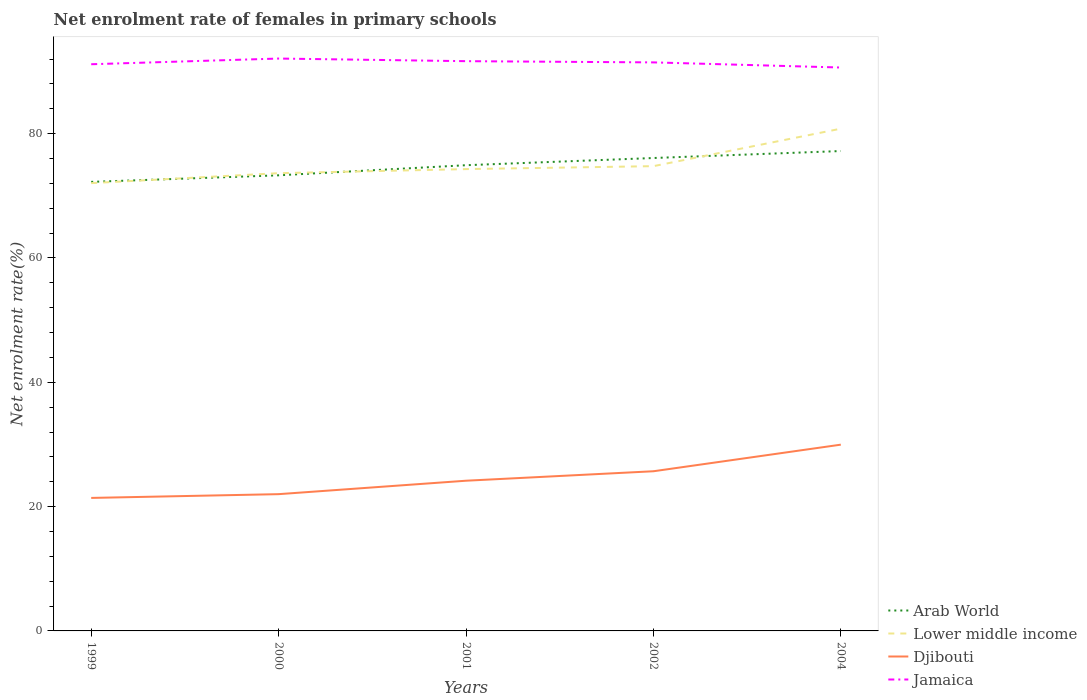How many different coloured lines are there?
Ensure brevity in your answer.  4. Is the number of lines equal to the number of legend labels?
Offer a very short reply. Yes. Across all years, what is the maximum net enrolment rate of females in primary schools in Lower middle income?
Your answer should be very brief. 72.04. What is the total net enrolment rate of females in primary schools in Arab World in the graph?
Offer a terse response. -1.12. What is the difference between the highest and the second highest net enrolment rate of females in primary schools in Jamaica?
Keep it short and to the point. 1.44. How many years are there in the graph?
Your response must be concise. 5. What is the difference between two consecutive major ticks on the Y-axis?
Provide a short and direct response. 20. Are the values on the major ticks of Y-axis written in scientific E-notation?
Offer a terse response. No. Does the graph contain any zero values?
Give a very brief answer. No. Where does the legend appear in the graph?
Keep it short and to the point. Bottom right. How many legend labels are there?
Offer a terse response. 4. What is the title of the graph?
Your response must be concise. Net enrolment rate of females in primary schools. Does "Egypt, Arab Rep." appear as one of the legend labels in the graph?
Your answer should be very brief. No. What is the label or title of the X-axis?
Offer a terse response. Years. What is the label or title of the Y-axis?
Your answer should be very brief. Net enrolment rate(%). What is the Net enrolment rate(%) in Arab World in 1999?
Your response must be concise. 72.25. What is the Net enrolment rate(%) in Lower middle income in 1999?
Offer a terse response. 72.04. What is the Net enrolment rate(%) in Djibouti in 1999?
Keep it short and to the point. 21.4. What is the Net enrolment rate(%) in Jamaica in 1999?
Your answer should be compact. 91.17. What is the Net enrolment rate(%) in Arab World in 2000?
Provide a short and direct response. 73.3. What is the Net enrolment rate(%) of Lower middle income in 2000?
Keep it short and to the point. 73.64. What is the Net enrolment rate(%) in Djibouti in 2000?
Offer a terse response. 22. What is the Net enrolment rate(%) in Jamaica in 2000?
Offer a very short reply. 92.09. What is the Net enrolment rate(%) in Arab World in 2001?
Provide a succinct answer. 74.93. What is the Net enrolment rate(%) of Lower middle income in 2001?
Offer a terse response. 74.3. What is the Net enrolment rate(%) in Djibouti in 2001?
Give a very brief answer. 24.17. What is the Net enrolment rate(%) in Jamaica in 2001?
Keep it short and to the point. 91.67. What is the Net enrolment rate(%) of Arab World in 2002?
Provide a succinct answer. 76.09. What is the Net enrolment rate(%) of Lower middle income in 2002?
Provide a succinct answer. 74.78. What is the Net enrolment rate(%) of Djibouti in 2002?
Provide a short and direct response. 25.69. What is the Net enrolment rate(%) of Jamaica in 2002?
Offer a very short reply. 91.47. What is the Net enrolment rate(%) of Arab World in 2004?
Keep it short and to the point. 77.21. What is the Net enrolment rate(%) of Lower middle income in 2004?
Offer a terse response. 80.8. What is the Net enrolment rate(%) of Djibouti in 2004?
Ensure brevity in your answer.  29.97. What is the Net enrolment rate(%) in Jamaica in 2004?
Your answer should be compact. 90.64. Across all years, what is the maximum Net enrolment rate(%) of Arab World?
Offer a very short reply. 77.21. Across all years, what is the maximum Net enrolment rate(%) in Lower middle income?
Make the answer very short. 80.8. Across all years, what is the maximum Net enrolment rate(%) of Djibouti?
Ensure brevity in your answer.  29.97. Across all years, what is the maximum Net enrolment rate(%) of Jamaica?
Offer a terse response. 92.09. Across all years, what is the minimum Net enrolment rate(%) of Arab World?
Your response must be concise. 72.25. Across all years, what is the minimum Net enrolment rate(%) of Lower middle income?
Make the answer very short. 72.04. Across all years, what is the minimum Net enrolment rate(%) in Djibouti?
Provide a short and direct response. 21.4. Across all years, what is the minimum Net enrolment rate(%) of Jamaica?
Offer a terse response. 90.64. What is the total Net enrolment rate(%) of Arab World in the graph?
Offer a terse response. 373.77. What is the total Net enrolment rate(%) of Lower middle income in the graph?
Your response must be concise. 375.57. What is the total Net enrolment rate(%) in Djibouti in the graph?
Keep it short and to the point. 123.22. What is the total Net enrolment rate(%) of Jamaica in the graph?
Ensure brevity in your answer.  457.04. What is the difference between the Net enrolment rate(%) of Arab World in 1999 and that in 2000?
Provide a short and direct response. -1.06. What is the difference between the Net enrolment rate(%) of Lower middle income in 1999 and that in 2000?
Make the answer very short. -1.6. What is the difference between the Net enrolment rate(%) of Djibouti in 1999 and that in 2000?
Your answer should be very brief. -0.61. What is the difference between the Net enrolment rate(%) of Jamaica in 1999 and that in 2000?
Make the answer very short. -0.92. What is the difference between the Net enrolment rate(%) in Arab World in 1999 and that in 2001?
Give a very brief answer. -2.68. What is the difference between the Net enrolment rate(%) in Lower middle income in 1999 and that in 2001?
Provide a short and direct response. -2.26. What is the difference between the Net enrolment rate(%) in Djibouti in 1999 and that in 2001?
Offer a terse response. -2.77. What is the difference between the Net enrolment rate(%) of Jamaica in 1999 and that in 2001?
Provide a succinct answer. -0.49. What is the difference between the Net enrolment rate(%) in Arab World in 1999 and that in 2002?
Make the answer very short. -3.84. What is the difference between the Net enrolment rate(%) of Lower middle income in 1999 and that in 2002?
Your response must be concise. -2.73. What is the difference between the Net enrolment rate(%) of Djibouti in 1999 and that in 2002?
Make the answer very short. -4.29. What is the difference between the Net enrolment rate(%) of Jamaica in 1999 and that in 2002?
Ensure brevity in your answer.  -0.3. What is the difference between the Net enrolment rate(%) of Arab World in 1999 and that in 2004?
Ensure brevity in your answer.  -4.96. What is the difference between the Net enrolment rate(%) in Lower middle income in 1999 and that in 2004?
Offer a terse response. -8.76. What is the difference between the Net enrolment rate(%) of Djibouti in 1999 and that in 2004?
Provide a succinct answer. -8.57. What is the difference between the Net enrolment rate(%) in Jamaica in 1999 and that in 2004?
Make the answer very short. 0.53. What is the difference between the Net enrolment rate(%) in Arab World in 2000 and that in 2001?
Your answer should be very brief. -1.63. What is the difference between the Net enrolment rate(%) in Lower middle income in 2000 and that in 2001?
Your answer should be very brief. -0.66. What is the difference between the Net enrolment rate(%) of Djibouti in 2000 and that in 2001?
Your answer should be very brief. -2.16. What is the difference between the Net enrolment rate(%) of Jamaica in 2000 and that in 2001?
Provide a succinct answer. 0.42. What is the difference between the Net enrolment rate(%) of Arab World in 2000 and that in 2002?
Ensure brevity in your answer.  -2.78. What is the difference between the Net enrolment rate(%) in Lower middle income in 2000 and that in 2002?
Provide a short and direct response. -1.13. What is the difference between the Net enrolment rate(%) in Djibouti in 2000 and that in 2002?
Make the answer very short. -3.68. What is the difference between the Net enrolment rate(%) in Jamaica in 2000 and that in 2002?
Offer a terse response. 0.62. What is the difference between the Net enrolment rate(%) of Arab World in 2000 and that in 2004?
Your answer should be compact. -3.9. What is the difference between the Net enrolment rate(%) of Lower middle income in 2000 and that in 2004?
Give a very brief answer. -7.16. What is the difference between the Net enrolment rate(%) in Djibouti in 2000 and that in 2004?
Give a very brief answer. -7.96. What is the difference between the Net enrolment rate(%) of Jamaica in 2000 and that in 2004?
Provide a succinct answer. 1.44. What is the difference between the Net enrolment rate(%) in Arab World in 2001 and that in 2002?
Make the answer very short. -1.16. What is the difference between the Net enrolment rate(%) in Lower middle income in 2001 and that in 2002?
Provide a succinct answer. -0.47. What is the difference between the Net enrolment rate(%) in Djibouti in 2001 and that in 2002?
Offer a terse response. -1.52. What is the difference between the Net enrolment rate(%) of Jamaica in 2001 and that in 2002?
Provide a succinct answer. 0.2. What is the difference between the Net enrolment rate(%) in Arab World in 2001 and that in 2004?
Offer a terse response. -2.28. What is the difference between the Net enrolment rate(%) in Lower middle income in 2001 and that in 2004?
Your answer should be very brief. -6.5. What is the difference between the Net enrolment rate(%) in Djibouti in 2001 and that in 2004?
Provide a succinct answer. -5.8. What is the difference between the Net enrolment rate(%) in Jamaica in 2001 and that in 2004?
Provide a succinct answer. 1.02. What is the difference between the Net enrolment rate(%) of Arab World in 2002 and that in 2004?
Your answer should be very brief. -1.12. What is the difference between the Net enrolment rate(%) of Lower middle income in 2002 and that in 2004?
Ensure brevity in your answer.  -6.03. What is the difference between the Net enrolment rate(%) in Djibouti in 2002 and that in 2004?
Your answer should be compact. -4.28. What is the difference between the Net enrolment rate(%) in Jamaica in 2002 and that in 2004?
Provide a succinct answer. 0.82. What is the difference between the Net enrolment rate(%) in Arab World in 1999 and the Net enrolment rate(%) in Lower middle income in 2000?
Your response must be concise. -1.4. What is the difference between the Net enrolment rate(%) in Arab World in 1999 and the Net enrolment rate(%) in Djibouti in 2000?
Give a very brief answer. 50.24. What is the difference between the Net enrolment rate(%) of Arab World in 1999 and the Net enrolment rate(%) of Jamaica in 2000?
Give a very brief answer. -19.84. What is the difference between the Net enrolment rate(%) in Lower middle income in 1999 and the Net enrolment rate(%) in Djibouti in 2000?
Provide a succinct answer. 50.04. What is the difference between the Net enrolment rate(%) in Lower middle income in 1999 and the Net enrolment rate(%) in Jamaica in 2000?
Offer a very short reply. -20.04. What is the difference between the Net enrolment rate(%) in Djibouti in 1999 and the Net enrolment rate(%) in Jamaica in 2000?
Your response must be concise. -70.69. What is the difference between the Net enrolment rate(%) of Arab World in 1999 and the Net enrolment rate(%) of Lower middle income in 2001?
Give a very brief answer. -2.05. What is the difference between the Net enrolment rate(%) in Arab World in 1999 and the Net enrolment rate(%) in Djibouti in 2001?
Provide a short and direct response. 48.08. What is the difference between the Net enrolment rate(%) of Arab World in 1999 and the Net enrolment rate(%) of Jamaica in 2001?
Provide a short and direct response. -19.42. What is the difference between the Net enrolment rate(%) in Lower middle income in 1999 and the Net enrolment rate(%) in Djibouti in 2001?
Provide a succinct answer. 47.88. What is the difference between the Net enrolment rate(%) of Lower middle income in 1999 and the Net enrolment rate(%) of Jamaica in 2001?
Keep it short and to the point. -19.62. What is the difference between the Net enrolment rate(%) in Djibouti in 1999 and the Net enrolment rate(%) in Jamaica in 2001?
Keep it short and to the point. -70.27. What is the difference between the Net enrolment rate(%) in Arab World in 1999 and the Net enrolment rate(%) in Lower middle income in 2002?
Make the answer very short. -2.53. What is the difference between the Net enrolment rate(%) of Arab World in 1999 and the Net enrolment rate(%) of Djibouti in 2002?
Provide a succinct answer. 46.56. What is the difference between the Net enrolment rate(%) of Arab World in 1999 and the Net enrolment rate(%) of Jamaica in 2002?
Ensure brevity in your answer.  -19.22. What is the difference between the Net enrolment rate(%) in Lower middle income in 1999 and the Net enrolment rate(%) in Djibouti in 2002?
Offer a very short reply. 46.36. What is the difference between the Net enrolment rate(%) of Lower middle income in 1999 and the Net enrolment rate(%) of Jamaica in 2002?
Offer a very short reply. -19.42. What is the difference between the Net enrolment rate(%) in Djibouti in 1999 and the Net enrolment rate(%) in Jamaica in 2002?
Provide a succinct answer. -70.07. What is the difference between the Net enrolment rate(%) of Arab World in 1999 and the Net enrolment rate(%) of Lower middle income in 2004?
Your answer should be very brief. -8.56. What is the difference between the Net enrolment rate(%) of Arab World in 1999 and the Net enrolment rate(%) of Djibouti in 2004?
Give a very brief answer. 42.28. What is the difference between the Net enrolment rate(%) in Arab World in 1999 and the Net enrolment rate(%) in Jamaica in 2004?
Offer a terse response. -18.4. What is the difference between the Net enrolment rate(%) of Lower middle income in 1999 and the Net enrolment rate(%) of Djibouti in 2004?
Keep it short and to the point. 42.08. What is the difference between the Net enrolment rate(%) in Lower middle income in 1999 and the Net enrolment rate(%) in Jamaica in 2004?
Your answer should be compact. -18.6. What is the difference between the Net enrolment rate(%) in Djibouti in 1999 and the Net enrolment rate(%) in Jamaica in 2004?
Provide a succinct answer. -69.25. What is the difference between the Net enrolment rate(%) of Arab World in 2000 and the Net enrolment rate(%) of Lower middle income in 2001?
Your response must be concise. -1. What is the difference between the Net enrolment rate(%) in Arab World in 2000 and the Net enrolment rate(%) in Djibouti in 2001?
Your answer should be compact. 49.14. What is the difference between the Net enrolment rate(%) in Arab World in 2000 and the Net enrolment rate(%) in Jamaica in 2001?
Your answer should be very brief. -18.36. What is the difference between the Net enrolment rate(%) of Lower middle income in 2000 and the Net enrolment rate(%) of Djibouti in 2001?
Provide a succinct answer. 49.48. What is the difference between the Net enrolment rate(%) in Lower middle income in 2000 and the Net enrolment rate(%) in Jamaica in 2001?
Your answer should be very brief. -18.02. What is the difference between the Net enrolment rate(%) of Djibouti in 2000 and the Net enrolment rate(%) of Jamaica in 2001?
Offer a very short reply. -69.66. What is the difference between the Net enrolment rate(%) in Arab World in 2000 and the Net enrolment rate(%) in Lower middle income in 2002?
Offer a terse response. -1.47. What is the difference between the Net enrolment rate(%) of Arab World in 2000 and the Net enrolment rate(%) of Djibouti in 2002?
Your answer should be very brief. 47.61. What is the difference between the Net enrolment rate(%) of Arab World in 2000 and the Net enrolment rate(%) of Jamaica in 2002?
Your answer should be compact. -18.17. What is the difference between the Net enrolment rate(%) of Lower middle income in 2000 and the Net enrolment rate(%) of Djibouti in 2002?
Offer a terse response. 47.96. What is the difference between the Net enrolment rate(%) in Lower middle income in 2000 and the Net enrolment rate(%) in Jamaica in 2002?
Your answer should be very brief. -17.82. What is the difference between the Net enrolment rate(%) in Djibouti in 2000 and the Net enrolment rate(%) in Jamaica in 2002?
Make the answer very short. -69.47. What is the difference between the Net enrolment rate(%) of Arab World in 2000 and the Net enrolment rate(%) of Lower middle income in 2004?
Your answer should be compact. -7.5. What is the difference between the Net enrolment rate(%) of Arab World in 2000 and the Net enrolment rate(%) of Djibouti in 2004?
Offer a terse response. 43.33. What is the difference between the Net enrolment rate(%) in Arab World in 2000 and the Net enrolment rate(%) in Jamaica in 2004?
Provide a succinct answer. -17.34. What is the difference between the Net enrolment rate(%) of Lower middle income in 2000 and the Net enrolment rate(%) of Djibouti in 2004?
Your answer should be very brief. 43.68. What is the difference between the Net enrolment rate(%) of Lower middle income in 2000 and the Net enrolment rate(%) of Jamaica in 2004?
Your answer should be compact. -17. What is the difference between the Net enrolment rate(%) in Djibouti in 2000 and the Net enrolment rate(%) in Jamaica in 2004?
Keep it short and to the point. -68.64. What is the difference between the Net enrolment rate(%) in Arab World in 2001 and the Net enrolment rate(%) in Lower middle income in 2002?
Your answer should be very brief. 0.15. What is the difference between the Net enrolment rate(%) in Arab World in 2001 and the Net enrolment rate(%) in Djibouti in 2002?
Your answer should be compact. 49.24. What is the difference between the Net enrolment rate(%) of Arab World in 2001 and the Net enrolment rate(%) of Jamaica in 2002?
Your answer should be compact. -16.54. What is the difference between the Net enrolment rate(%) in Lower middle income in 2001 and the Net enrolment rate(%) in Djibouti in 2002?
Make the answer very short. 48.61. What is the difference between the Net enrolment rate(%) in Lower middle income in 2001 and the Net enrolment rate(%) in Jamaica in 2002?
Offer a very short reply. -17.17. What is the difference between the Net enrolment rate(%) of Djibouti in 2001 and the Net enrolment rate(%) of Jamaica in 2002?
Give a very brief answer. -67.3. What is the difference between the Net enrolment rate(%) in Arab World in 2001 and the Net enrolment rate(%) in Lower middle income in 2004?
Provide a succinct answer. -5.88. What is the difference between the Net enrolment rate(%) of Arab World in 2001 and the Net enrolment rate(%) of Djibouti in 2004?
Your answer should be compact. 44.96. What is the difference between the Net enrolment rate(%) of Arab World in 2001 and the Net enrolment rate(%) of Jamaica in 2004?
Keep it short and to the point. -15.72. What is the difference between the Net enrolment rate(%) of Lower middle income in 2001 and the Net enrolment rate(%) of Djibouti in 2004?
Offer a terse response. 44.33. What is the difference between the Net enrolment rate(%) of Lower middle income in 2001 and the Net enrolment rate(%) of Jamaica in 2004?
Provide a short and direct response. -16.34. What is the difference between the Net enrolment rate(%) in Djibouti in 2001 and the Net enrolment rate(%) in Jamaica in 2004?
Your response must be concise. -66.48. What is the difference between the Net enrolment rate(%) in Arab World in 2002 and the Net enrolment rate(%) in Lower middle income in 2004?
Offer a very short reply. -4.72. What is the difference between the Net enrolment rate(%) of Arab World in 2002 and the Net enrolment rate(%) of Djibouti in 2004?
Make the answer very short. 46.12. What is the difference between the Net enrolment rate(%) in Arab World in 2002 and the Net enrolment rate(%) in Jamaica in 2004?
Your answer should be very brief. -14.56. What is the difference between the Net enrolment rate(%) in Lower middle income in 2002 and the Net enrolment rate(%) in Djibouti in 2004?
Your answer should be compact. 44.81. What is the difference between the Net enrolment rate(%) in Lower middle income in 2002 and the Net enrolment rate(%) in Jamaica in 2004?
Keep it short and to the point. -15.87. What is the difference between the Net enrolment rate(%) in Djibouti in 2002 and the Net enrolment rate(%) in Jamaica in 2004?
Your answer should be very brief. -64.96. What is the average Net enrolment rate(%) of Arab World per year?
Ensure brevity in your answer.  74.75. What is the average Net enrolment rate(%) in Lower middle income per year?
Provide a succinct answer. 75.11. What is the average Net enrolment rate(%) in Djibouti per year?
Offer a terse response. 24.64. What is the average Net enrolment rate(%) of Jamaica per year?
Your response must be concise. 91.41. In the year 1999, what is the difference between the Net enrolment rate(%) of Arab World and Net enrolment rate(%) of Lower middle income?
Provide a succinct answer. 0.2. In the year 1999, what is the difference between the Net enrolment rate(%) in Arab World and Net enrolment rate(%) in Djibouti?
Make the answer very short. 50.85. In the year 1999, what is the difference between the Net enrolment rate(%) in Arab World and Net enrolment rate(%) in Jamaica?
Make the answer very short. -18.93. In the year 1999, what is the difference between the Net enrolment rate(%) of Lower middle income and Net enrolment rate(%) of Djibouti?
Ensure brevity in your answer.  50.65. In the year 1999, what is the difference between the Net enrolment rate(%) in Lower middle income and Net enrolment rate(%) in Jamaica?
Keep it short and to the point. -19.13. In the year 1999, what is the difference between the Net enrolment rate(%) in Djibouti and Net enrolment rate(%) in Jamaica?
Keep it short and to the point. -69.77. In the year 2000, what is the difference between the Net enrolment rate(%) in Arab World and Net enrolment rate(%) in Lower middle income?
Provide a succinct answer. -0.34. In the year 2000, what is the difference between the Net enrolment rate(%) in Arab World and Net enrolment rate(%) in Djibouti?
Keep it short and to the point. 51.3. In the year 2000, what is the difference between the Net enrolment rate(%) in Arab World and Net enrolment rate(%) in Jamaica?
Provide a short and direct response. -18.79. In the year 2000, what is the difference between the Net enrolment rate(%) in Lower middle income and Net enrolment rate(%) in Djibouti?
Offer a very short reply. 51.64. In the year 2000, what is the difference between the Net enrolment rate(%) of Lower middle income and Net enrolment rate(%) of Jamaica?
Offer a very short reply. -18.44. In the year 2000, what is the difference between the Net enrolment rate(%) in Djibouti and Net enrolment rate(%) in Jamaica?
Offer a very short reply. -70.08. In the year 2001, what is the difference between the Net enrolment rate(%) in Arab World and Net enrolment rate(%) in Lower middle income?
Your response must be concise. 0.63. In the year 2001, what is the difference between the Net enrolment rate(%) of Arab World and Net enrolment rate(%) of Djibouti?
Your answer should be very brief. 50.76. In the year 2001, what is the difference between the Net enrolment rate(%) of Arab World and Net enrolment rate(%) of Jamaica?
Keep it short and to the point. -16.74. In the year 2001, what is the difference between the Net enrolment rate(%) of Lower middle income and Net enrolment rate(%) of Djibouti?
Your response must be concise. 50.14. In the year 2001, what is the difference between the Net enrolment rate(%) in Lower middle income and Net enrolment rate(%) in Jamaica?
Provide a short and direct response. -17.36. In the year 2001, what is the difference between the Net enrolment rate(%) of Djibouti and Net enrolment rate(%) of Jamaica?
Keep it short and to the point. -67.5. In the year 2002, what is the difference between the Net enrolment rate(%) in Arab World and Net enrolment rate(%) in Lower middle income?
Provide a short and direct response. 1.31. In the year 2002, what is the difference between the Net enrolment rate(%) in Arab World and Net enrolment rate(%) in Djibouti?
Your response must be concise. 50.4. In the year 2002, what is the difference between the Net enrolment rate(%) of Arab World and Net enrolment rate(%) of Jamaica?
Offer a very short reply. -15.38. In the year 2002, what is the difference between the Net enrolment rate(%) of Lower middle income and Net enrolment rate(%) of Djibouti?
Your answer should be compact. 49.09. In the year 2002, what is the difference between the Net enrolment rate(%) in Lower middle income and Net enrolment rate(%) in Jamaica?
Make the answer very short. -16.69. In the year 2002, what is the difference between the Net enrolment rate(%) in Djibouti and Net enrolment rate(%) in Jamaica?
Ensure brevity in your answer.  -65.78. In the year 2004, what is the difference between the Net enrolment rate(%) of Arab World and Net enrolment rate(%) of Lower middle income?
Your answer should be compact. -3.6. In the year 2004, what is the difference between the Net enrolment rate(%) of Arab World and Net enrolment rate(%) of Djibouti?
Provide a short and direct response. 47.24. In the year 2004, what is the difference between the Net enrolment rate(%) in Arab World and Net enrolment rate(%) in Jamaica?
Offer a terse response. -13.44. In the year 2004, what is the difference between the Net enrolment rate(%) in Lower middle income and Net enrolment rate(%) in Djibouti?
Provide a short and direct response. 50.84. In the year 2004, what is the difference between the Net enrolment rate(%) in Lower middle income and Net enrolment rate(%) in Jamaica?
Offer a terse response. -9.84. In the year 2004, what is the difference between the Net enrolment rate(%) of Djibouti and Net enrolment rate(%) of Jamaica?
Give a very brief answer. -60.68. What is the ratio of the Net enrolment rate(%) in Arab World in 1999 to that in 2000?
Offer a very short reply. 0.99. What is the ratio of the Net enrolment rate(%) of Lower middle income in 1999 to that in 2000?
Offer a terse response. 0.98. What is the ratio of the Net enrolment rate(%) in Djibouti in 1999 to that in 2000?
Make the answer very short. 0.97. What is the ratio of the Net enrolment rate(%) of Jamaica in 1999 to that in 2000?
Your response must be concise. 0.99. What is the ratio of the Net enrolment rate(%) in Arab World in 1999 to that in 2001?
Your answer should be very brief. 0.96. What is the ratio of the Net enrolment rate(%) of Lower middle income in 1999 to that in 2001?
Make the answer very short. 0.97. What is the ratio of the Net enrolment rate(%) in Djibouti in 1999 to that in 2001?
Offer a terse response. 0.89. What is the ratio of the Net enrolment rate(%) in Jamaica in 1999 to that in 2001?
Offer a terse response. 0.99. What is the ratio of the Net enrolment rate(%) in Arab World in 1999 to that in 2002?
Ensure brevity in your answer.  0.95. What is the ratio of the Net enrolment rate(%) of Lower middle income in 1999 to that in 2002?
Keep it short and to the point. 0.96. What is the ratio of the Net enrolment rate(%) in Djibouti in 1999 to that in 2002?
Give a very brief answer. 0.83. What is the ratio of the Net enrolment rate(%) in Arab World in 1999 to that in 2004?
Ensure brevity in your answer.  0.94. What is the ratio of the Net enrolment rate(%) in Lower middle income in 1999 to that in 2004?
Give a very brief answer. 0.89. What is the ratio of the Net enrolment rate(%) in Djibouti in 1999 to that in 2004?
Ensure brevity in your answer.  0.71. What is the ratio of the Net enrolment rate(%) in Jamaica in 1999 to that in 2004?
Offer a very short reply. 1.01. What is the ratio of the Net enrolment rate(%) in Arab World in 2000 to that in 2001?
Your response must be concise. 0.98. What is the ratio of the Net enrolment rate(%) in Lower middle income in 2000 to that in 2001?
Provide a short and direct response. 0.99. What is the ratio of the Net enrolment rate(%) of Djibouti in 2000 to that in 2001?
Make the answer very short. 0.91. What is the ratio of the Net enrolment rate(%) in Arab World in 2000 to that in 2002?
Ensure brevity in your answer.  0.96. What is the ratio of the Net enrolment rate(%) of Lower middle income in 2000 to that in 2002?
Keep it short and to the point. 0.98. What is the ratio of the Net enrolment rate(%) of Djibouti in 2000 to that in 2002?
Give a very brief answer. 0.86. What is the ratio of the Net enrolment rate(%) in Jamaica in 2000 to that in 2002?
Ensure brevity in your answer.  1.01. What is the ratio of the Net enrolment rate(%) in Arab World in 2000 to that in 2004?
Your answer should be very brief. 0.95. What is the ratio of the Net enrolment rate(%) of Lower middle income in 2000 to that in 2004?
Make the answer very short. 0.91. What is the ratio of the Net enrolment rate(%) in Djibouti in 2000 to that in 2004?
Ensure brevity in your answer.  0.73. What is the ratio of the Net enrolment rate(%) of Jamaica in 2000 to that in 2004?
Keep it short and to the point. 1.02. What is the ratio of the Net enrolment rate(%) in Arab World in 2001 to that in 2002?
Ensure brevity in your answer.  0.98. What is the ratio of the Net enrolment rate(%) of Lower middle income in 2001 to that in 2002?
Offer a very short reply. 0.99. What is the ratio of the Net enrolment rate(%) in Djibouti in 2001 to that in 2002?
Offer a terse response. 0.94. What is the ratio of the Net enrolment rate(%) of Jamaica in 2001 to that in 2002?
Your response must be concise. 1. What is the ratio of the Net enrolment rate(%) in Arab World in 2001 to that in 2004?
Keep it short and to the point. 0.97. What is the ratio of the Net enrolment rate(%) in Lower middle income in 2001 to that in 2004?
Your answer should be compact. 0.92. What is the ratio of the Net enrolment rate(%) in Djibouti in 2001 to that in 2004?
Your answer should be compact. 0.81. What is the ratio of the Net enrolment rate(%) of Jamaica in 2001 to that in 2004?
Provide a short and direct response. 1.01. What is the ratio of the Net enrolment rate(%) in Arab World in 2002 to that in 2004?
Offer a very short reply. 0.99. What is the ratio of the Net enrolment rate(%) of Lower middle income in 2002 to that in 2004?
Give a very brief answer. 0.93. What is the ratio of the Net enrolment rate(%) of Djibouti in 2002 to that in 2004?
Make the answer very short. 0.86. What is the ratio of the Net enrolment rate(%) in Jamaica in 2002 to that in 2004?
Offer a terse response. 1.01. What is the difference between the highest and the second highest Net enrolment rate(%) in Arab World?
Offer a terse response. 1.12. What is the difference between the highest and the second highest Net enrolment rate(%) of Lower middle income?
Provide a short and direct response. 6.03. What is the difference between the highest and the second highest Net enrolment rate(%) in Djibouti?
Your response must be concise. 4.28. What is the difference between the highest and the second highest Net enrolment rate(%) in Jamaica?
Give a very brief answer. 0.42. What is the difference between the highest and the lowest Net enrolment rate(%) of Arab World?
Offer a very short reply. 4.96. What is the difference between the highest and the lowest Net enrolment rate(%) in Lower middle income?
Offer a terse response. 8.76. What is the difference between the highest and the lowest Net enrolment rate(%) in Djibouti?
Provide a succinct answer. 8.57. What is the difference between the highest and the lowest Net enrolment rate(%) in Jamaica?
Your response must be concise. 1.44. 